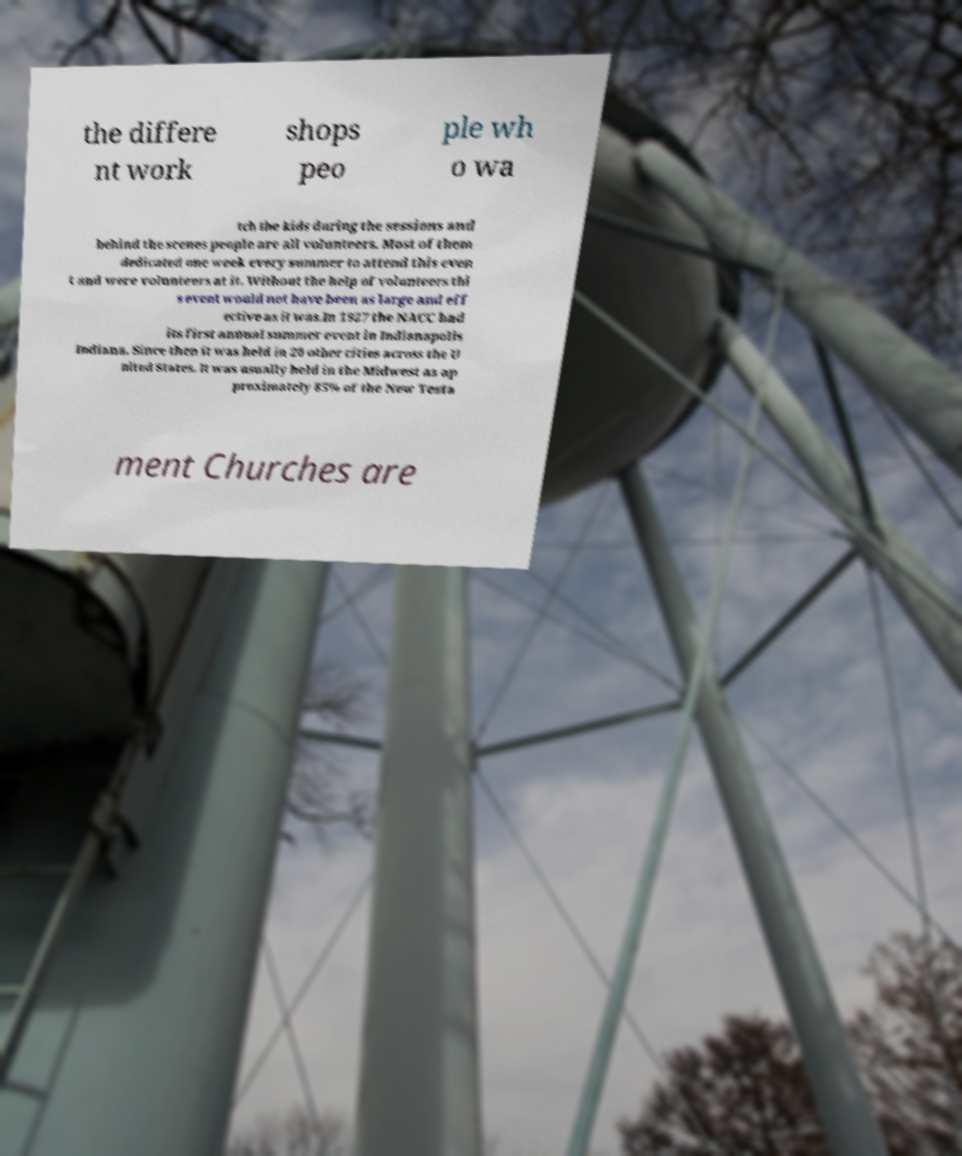Please read and relay the text visible in this image. What does it say? the differe nt work shops peo ple wh o wa tch the kids during the sessions and behind the scenes people are all volunteers. Most of them dedicated one week every summer to attend this even t and were volunteers at it. Without the help of volunteers thi s event would not have been as large and eff ective as it was.In 1927 the NACC had its first annual summer event in Indianapolis Indiana. Since then it was held in 20 other cities across the U nited States. It was usually held in the Midwest as ap proximately 85% of the New Testa ment Churches are 